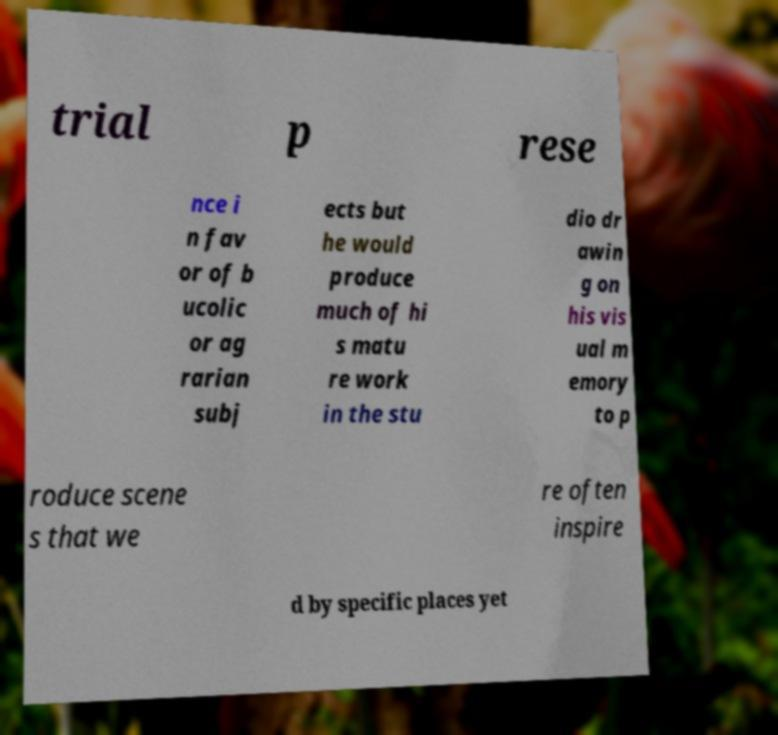Please read and relay the text visible in this image. What does it say? trial p rese nce i n fav or of b ucolic or ag rarian subj ects but he would produce much of hi s matu re work in the stu dio dr awin g on his vis ual m emory to p roduce scene s that we re often inspire d by specific places yet 